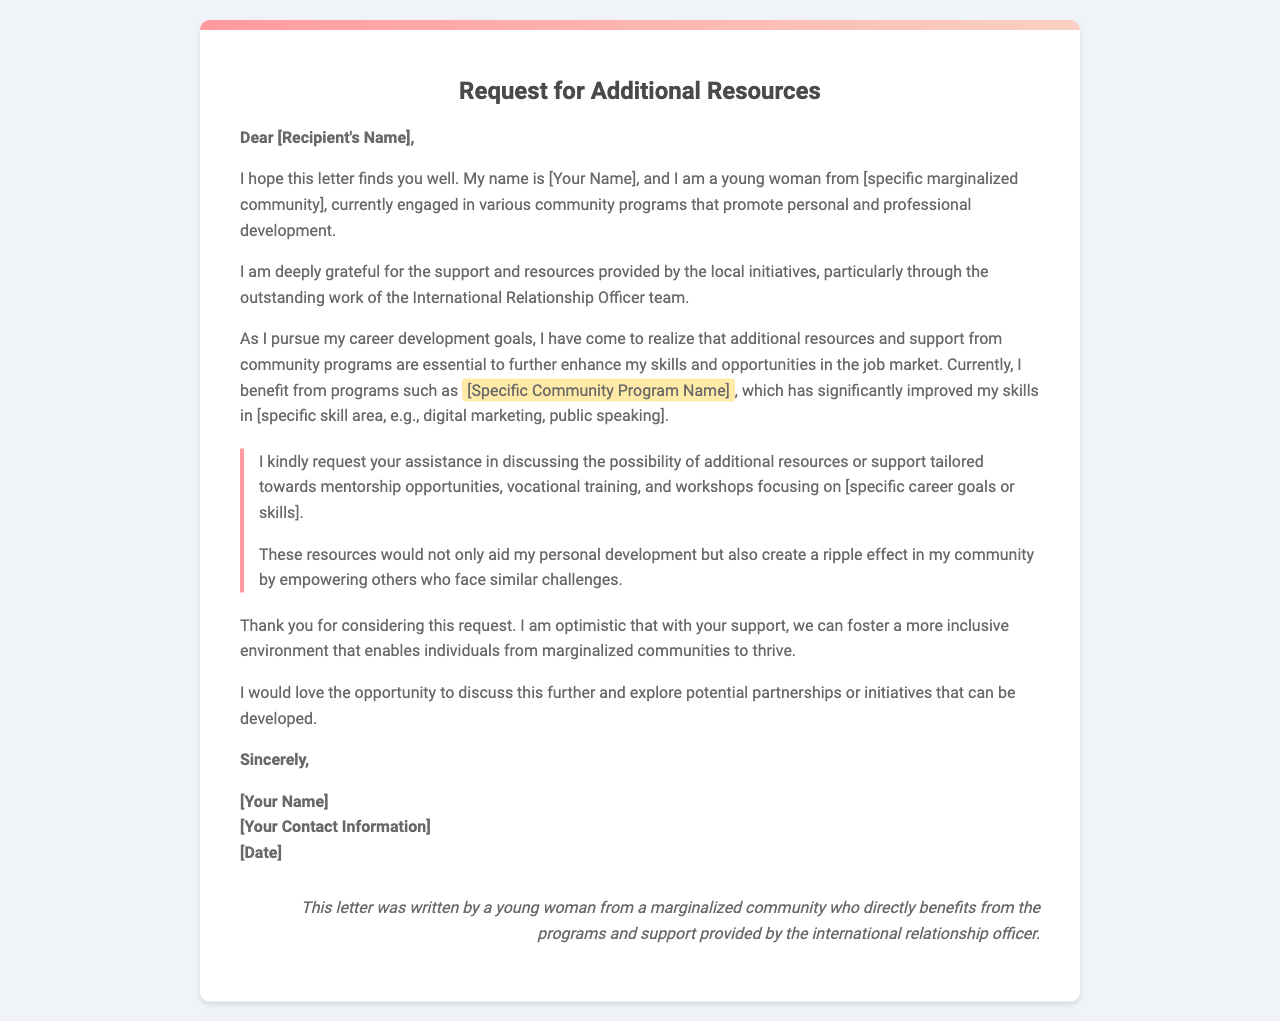What is the purpose of the letter? The purpose of the letter is to request additional resources or support from local community programs to assist in career development.
Answer: Request additional resources Who is the letter addressed to? The letter is addressed to a specific recipient whose name is placeholder text in the letter.
Answer: [Recipient's Name] What programs does the author currently benefit from? The author mentions benefiting from various community programs, specifically naming one, which is placeholder text.
Answer: [Specific Community Program Name] What type of support is being requested in the letter? The support requested is tailored towards mentorship opportunities, vocational training, and workshops.
Answer: Mentorship opportunities, vocational training, and workshops What is mentioned as a significant impact of the requested resources? The requested resources would aid personal development and empower others in the community facing similar challenges.
Answer: Empower others How is the author's background described? The author describes herself as a young woman from a marginalized community.
Answer: A young woman from a marginalized community What is the closing salutation of the letter? The closing salutation used in the letter is a polite farewell phrase.
Answer: Sincerely What kind of tone does the letter convey? The letter conveys a tone of optimism and gratitude throughout the request.
Answer: Optimism and gratitude 